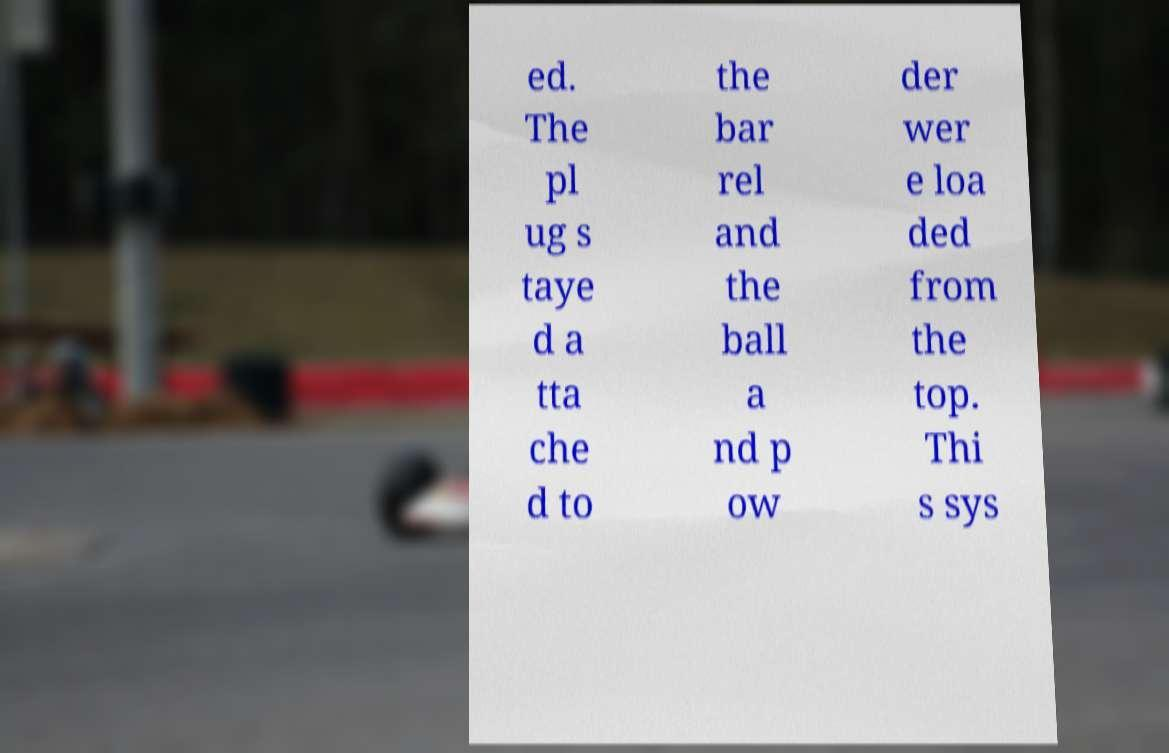Please read and relay the text visible in this image. What does it say? ed. The pl ug s taye d a tta che d to the bar rel and the ball a nd p ow der wer e loa ded from the top. Thi s sys 